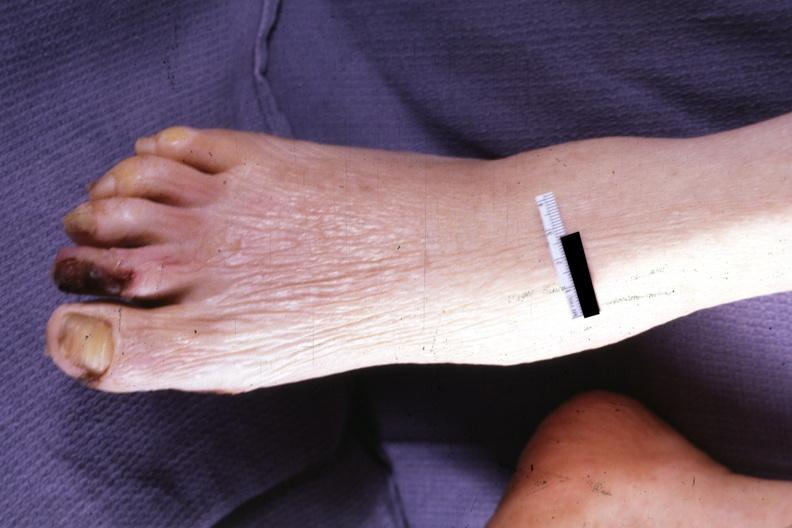s hemorrhage in newborn present?
Answer the question using a single word or phrase. No 